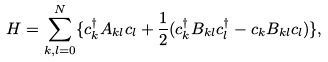Convert formula to latex. <formula><loc_0><loc_0><loc_500><loc_500>H = \sum _ { k , l = 0 } ^ { N } \{ c _ { k } ^ { \dagger } A _ { k l } c _ { l } + \frac { 1 } { 2 } ( c _ { k } ^ { \dagger } B _ { k l } c _ { l } ^ { \dagger } - c _ { k } B _ { k l } c _ { l } ) \} ,</formula> 